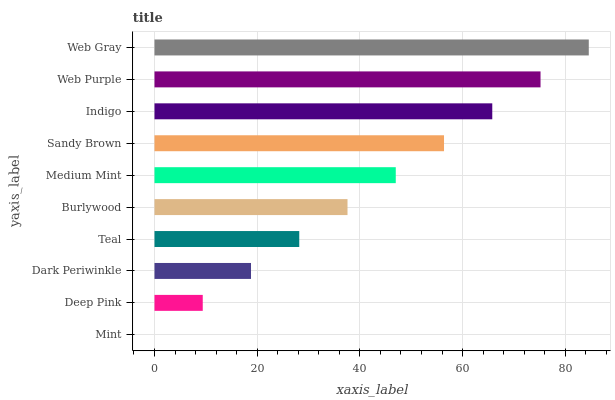Is Mint the minimum?
Answer yes or no. Yes. Is Web Gray the maximum?
Answer yes or no. Yes. Is Deep Pink the minimum?
Answer yes or no. No. Is Deep Pink the maximum?
Answer yes or no. No. Is Deep Pink greater than Mint?
Answer yes or no. Yes. Is Mint less than Deep Pink?
Answer yes or no. Yes. Is Mint greater than Deep Pink?
Answer yes or no. No. Is Deep Pink less than Mint?
Answer yes or no. No. Is Medium Mint the high median?
Answer yes or no. Yes. Is Burlywood the low median?
Answer yes or no. Yes. Is Mint the high median?
Answer yes or no. No. Is Deep Pink the low median?
Answer yes or no. No. 